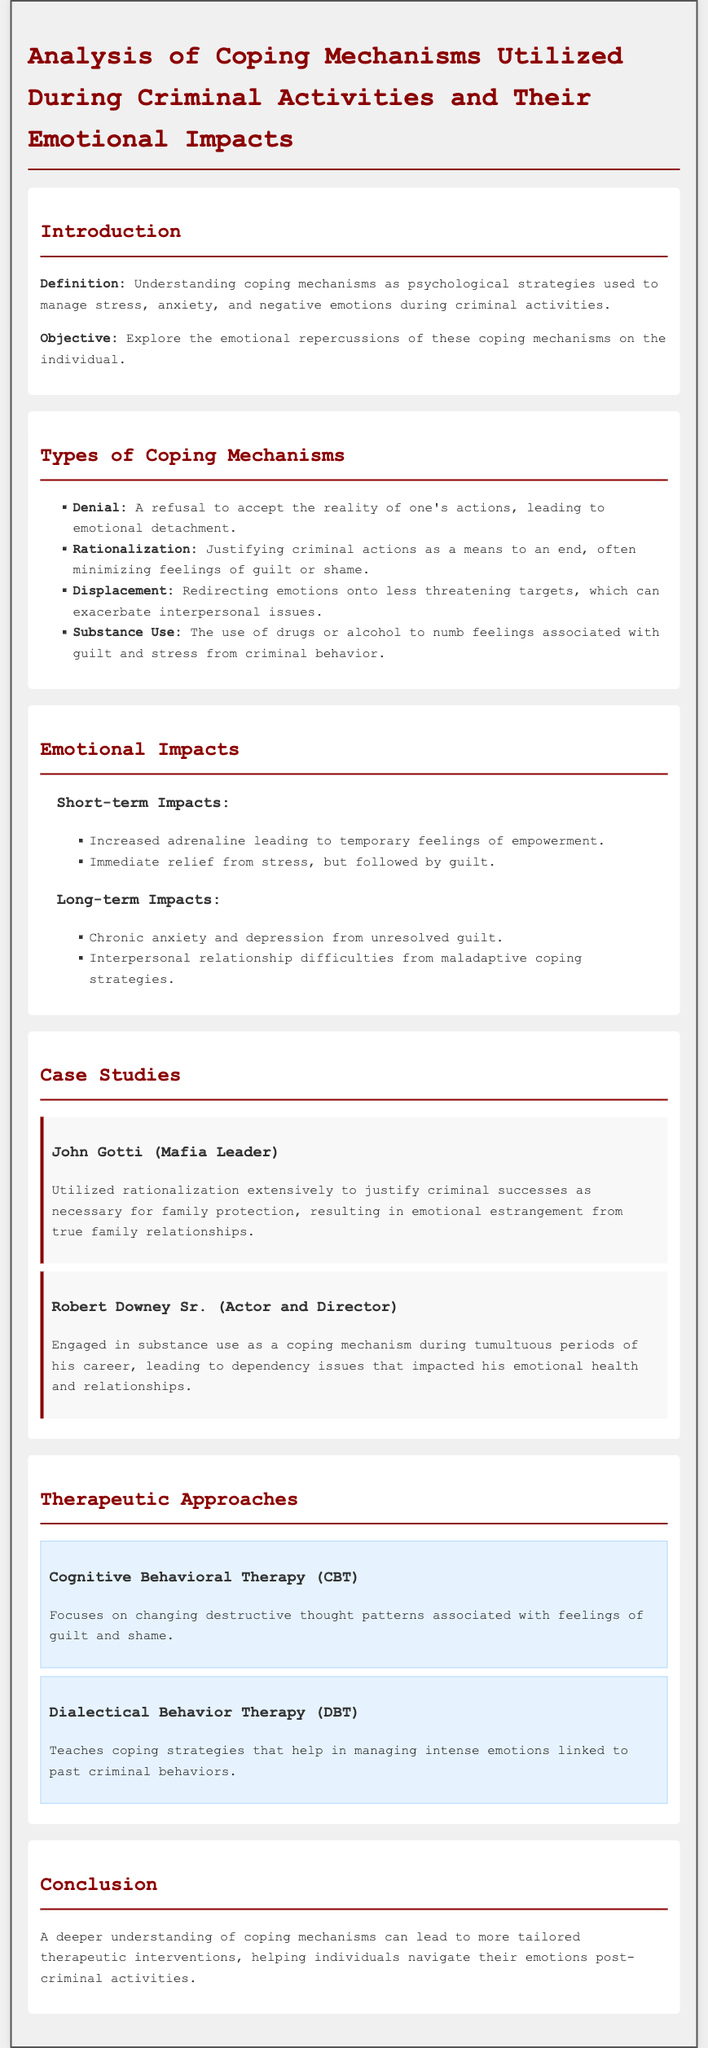What is the objective of the document? The objective is to explore the emotional repercussions of coping mechanisms on the individual.
Answer: Explore the emotional repercussions of coping mechanisms on the individual What coping mechanism involves refusing to accept reality? Denial is defined as a refusal to accept the reality of one's actions.
Answer: Denial What are the short-term impacts mentioned in the document? The document lists short-term impacts as increased adrenaline and immediate relief from stress, followed by guilt.
Answer: Increased adrenaline leading to temporary feelings of empowerment; Immediate relief from stress, but followed by guilt Which therapeutic approach focuses on changing destructive thought patterns? Cognitive Behavioral Therapy (CBT) is focused on changing destructive thought patterns associated with feelings of guilt and shame.
Answer: Cognitive Behavioral Therapy (CBT) Who engaged in substance use as a coping mechanism? Robert Downey Sr. is noted for engaging in substance use during tumultuous periods, impacting his emotional health.
Answer: Robert Downey Sr What is the primary focus of Dialectical Behavior Therapy (DBT)? DBT teaches coping strategies that help manage intense emotions linked to past criminal behaviors.
Answer: Coping strategies for managing intense emotions What long-term emotional impact is caused by unresolved guilt? Chronic anxiety and depression stem from unresolved guilt.
Answer: Chronic anxiety and depression 